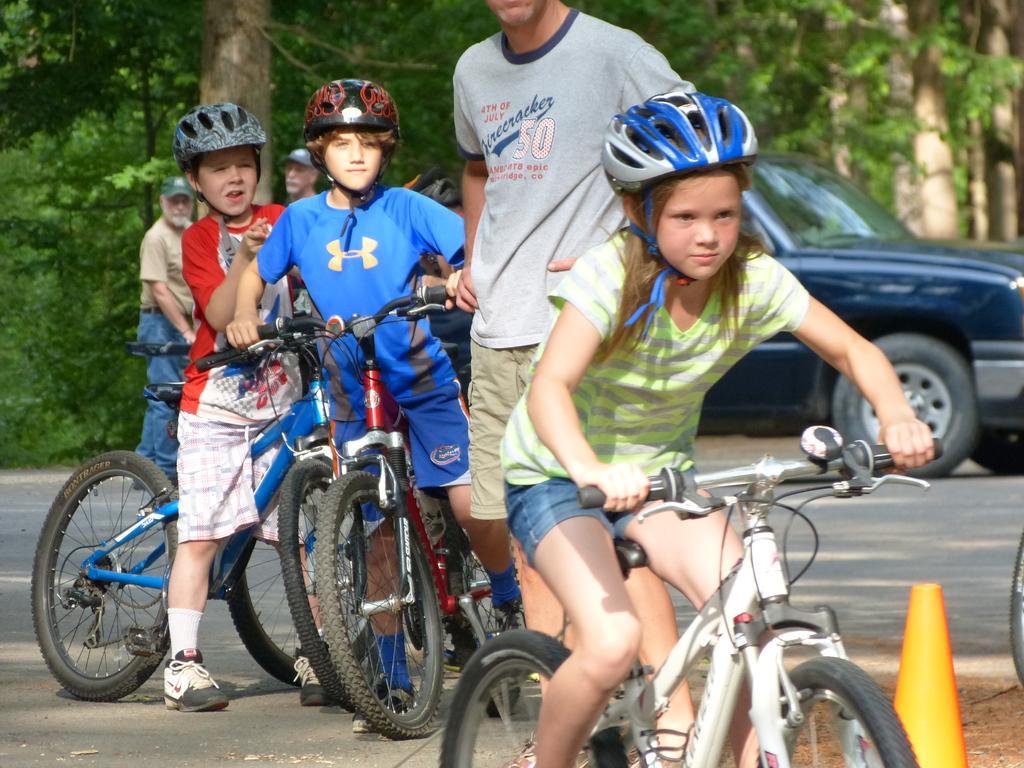What are the children doing in the image? The children are riding bicycles in the image. What safety precaution are the children taking while riding their bicycles? The children are wearing helmets. Can you describe the man standing in the image? There is a man standing in the image, but no specific details are provided about him. What can be seen in the background of the image? There is a car and trees visible in the background of the image, along with other people on the road. What type of underwear is the man wearing in the image? There is no man's underwear visible in the image, as the man standing in the image is not described in detail. What suggestion can be made to improve the health of the children in the image? The provided information does not allow for a suggestion to improve the health of the children, as their health is not mentioned in the facts. 